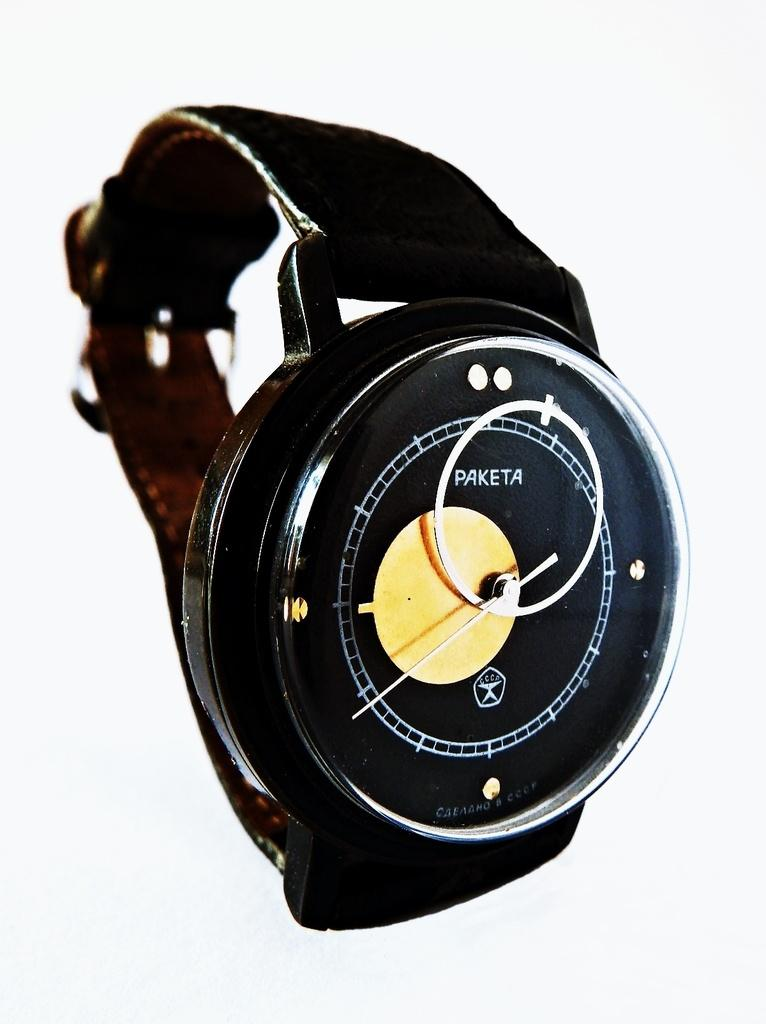<image>
Offer a succinct explanation of the picture presented. The Paketa watch has only a single hand. 